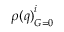Convert formula to latex. <formula><loc_0><loc_0><loc_500><loc_500>{ \rho ( q ) } _ { G = 0 } ^ { i }</formula> 